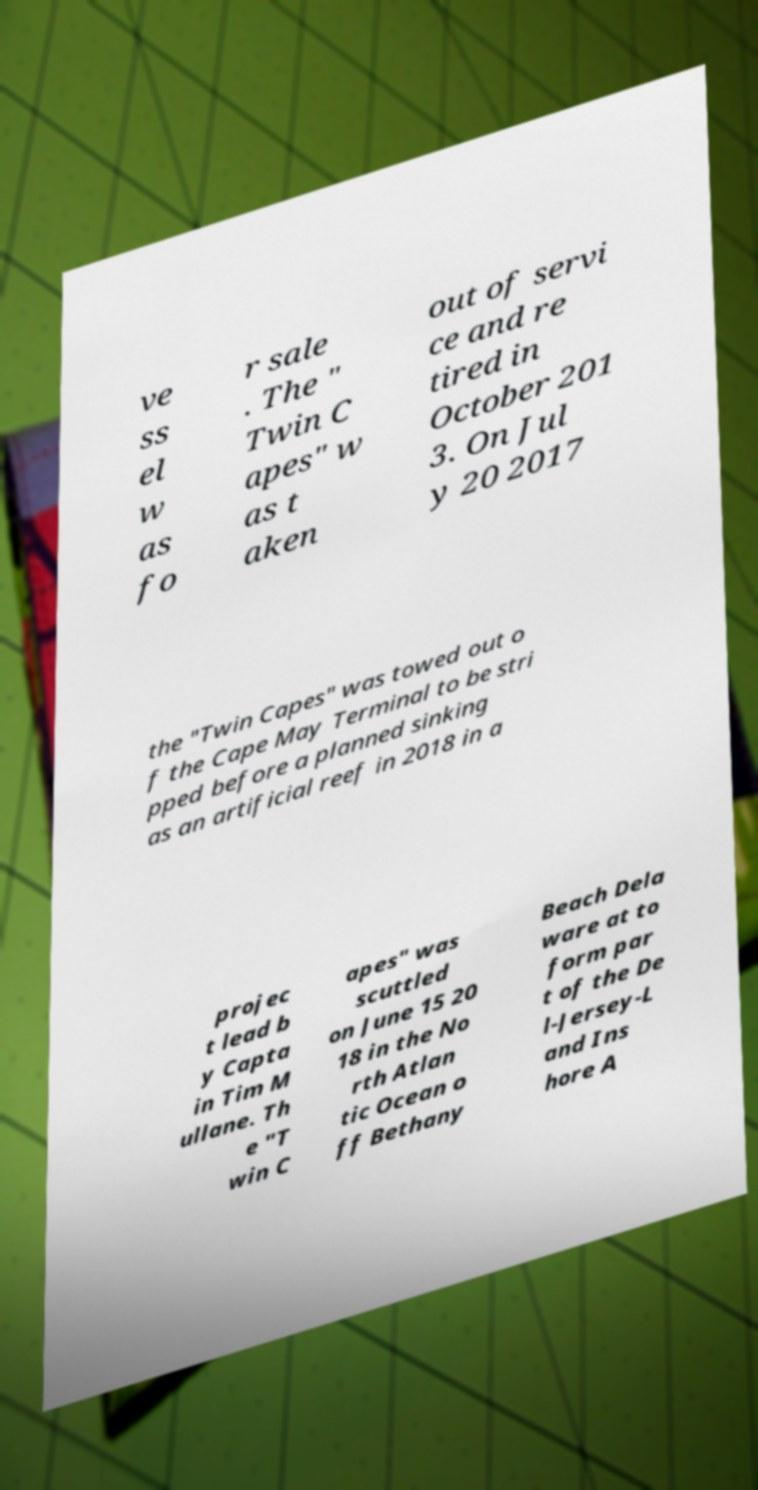There's text embedded in this image that I need extracted. Can you transcribe it verbatim? ve ss el w as fo r sale . The " Twin C apes" w as t aken out of servi ce and re tired in October 201 3. On Jul y 20 2017 the "Twin Capes" was towed out o f the Cape May Terminal to be stri pped before a planned sinking as an artificial reef in 2018 in a projec t lead b y Capta in Tim M ullane. Th e "T win C apes" was scuttled on June 15 20 18 in the No rth Atlan tic Ocean o ff Bethany Beach Dela ware at to form par t of the De l-Jersey-L and Ins hore A 